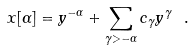<formula> <loc_0><loc_0><loc_500><loc_500>x [ \alpha ] = y ^ { - \alpha } + \sum _ { \gamma > - \alpha } c _ { \gamma } y ^ { \gamma } \ .</formula> 